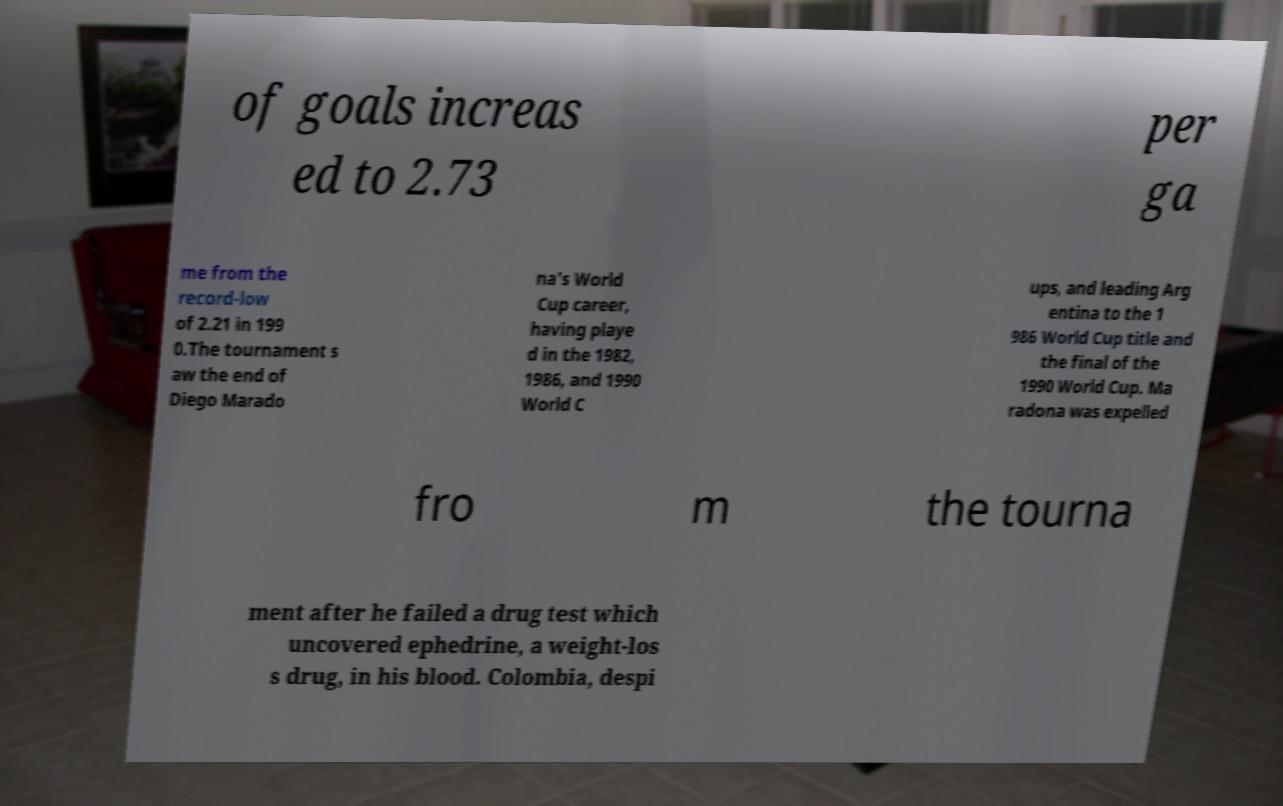For documentation purposes, I need the text within this image transcribed. Could you provide that? of goals increas ed to 2.73 per ga me from the record-low of 2.21 in 199 0.The tournament s aw the end of Diego Marado na's World Cup career, having playe d in the 1982, 1986, and 1990 World C ups, and leading Arg entina to the 1 986 World Cup title and the final of the 1990 World Cup. Ma radona was expelled fro m the tourna ment after he failed a drug test which uncovered ephedrine, a weight-los s drug, in his blood. Colombia, despi 